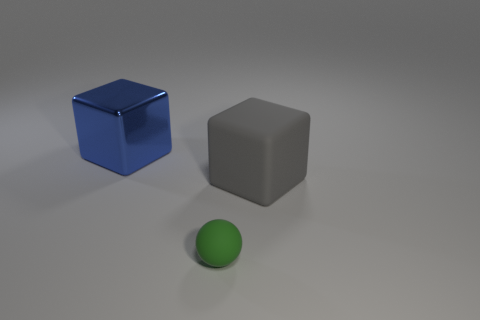How many gray objects are either rubber cubes or cylinders?
Make the answer very short. 1. How many big cubes are the same color as the ball?
Provide a short and direct response. 0. Are there any other things that are the same shape as the small object?
Keep it short and to the point. No. What number of balls are small green matte objects or blue objects?
Provide a succinct answer. 1. What is the color of the big cube that is in front of the blue cube?
Ensure brevity in your answer.  Gray. There is a object that is the same size as the gray block; what shape is it?
Ensure brevity in your answer.  Cube. There is a big metal block; what number of large rubber objects are to the right of it?
Ensure brevity in your answer.  1. What number of objects are big metal objects or large blocks?
Offer a very short reply. 2. There is a thing that is both left of the big gray rubber block and in front of the large metal object; what shape is it?
Your answer should be very brief. Sphere. What number of large blue cylinders are there?
Offer a terse response. 0. 